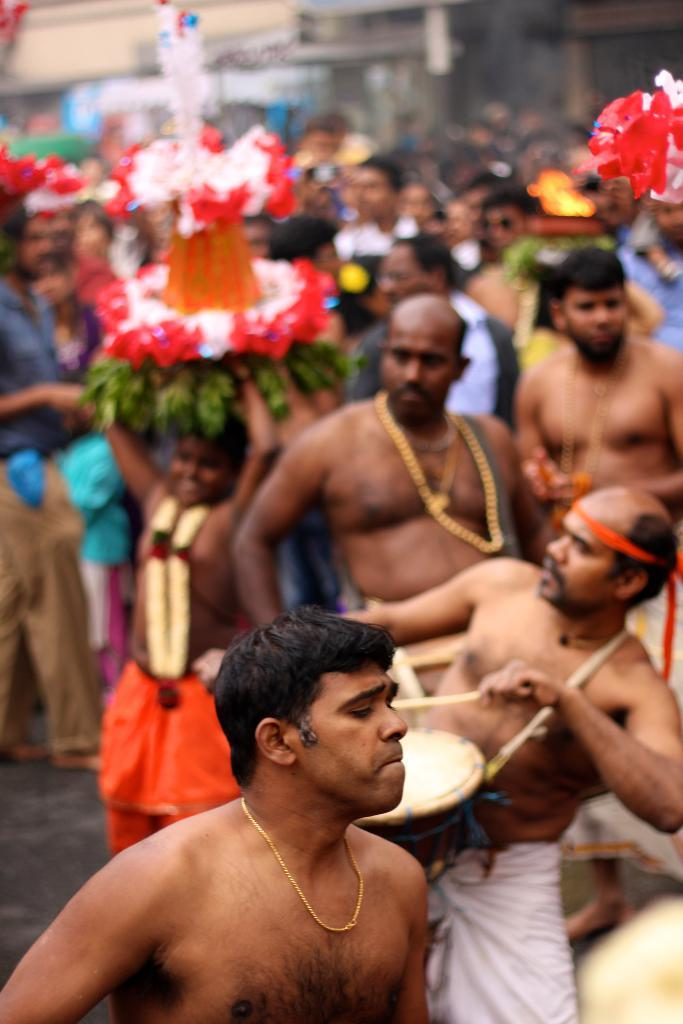What is happening on the road in the image? There is a group of people on the road in the image. What objects can be seen in the image besides the people? Chains, garland, sticks, and a drum are visible in the image. What is the background of the image like? There are buildings in the background, and it is blurry. Can you see any sea creatures in the image? There is no sea or sea creatures present in the image. What type of chalk is being used by the people in the image? There is no chalk visible in the image. 